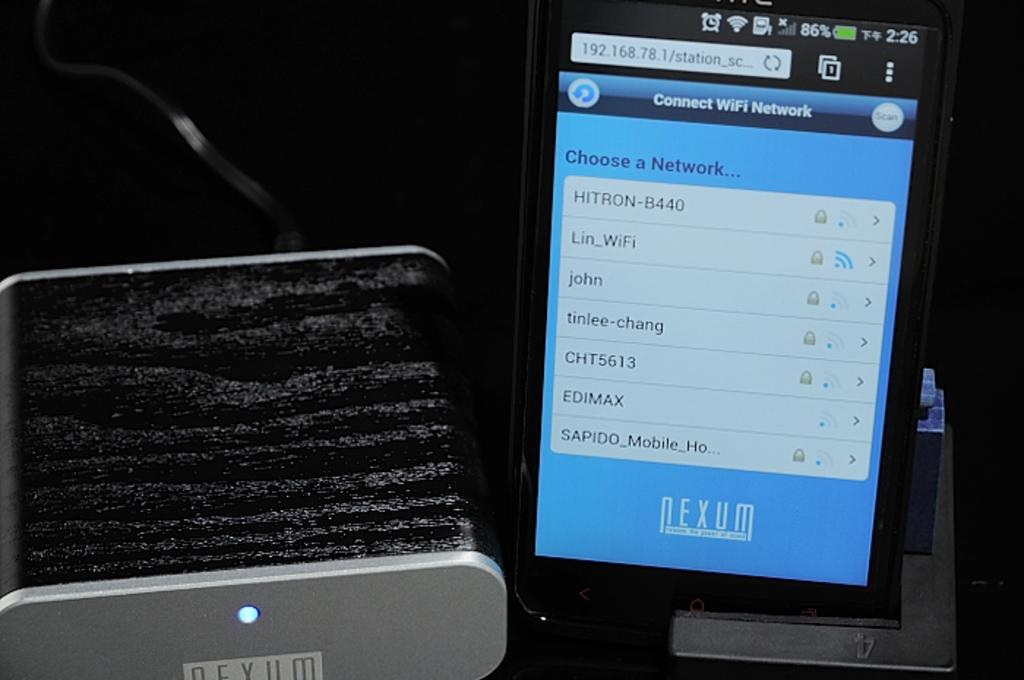Provide a one-sentence caption for the provided image. Among the networks the user can choose is one called tinlee-chang. 